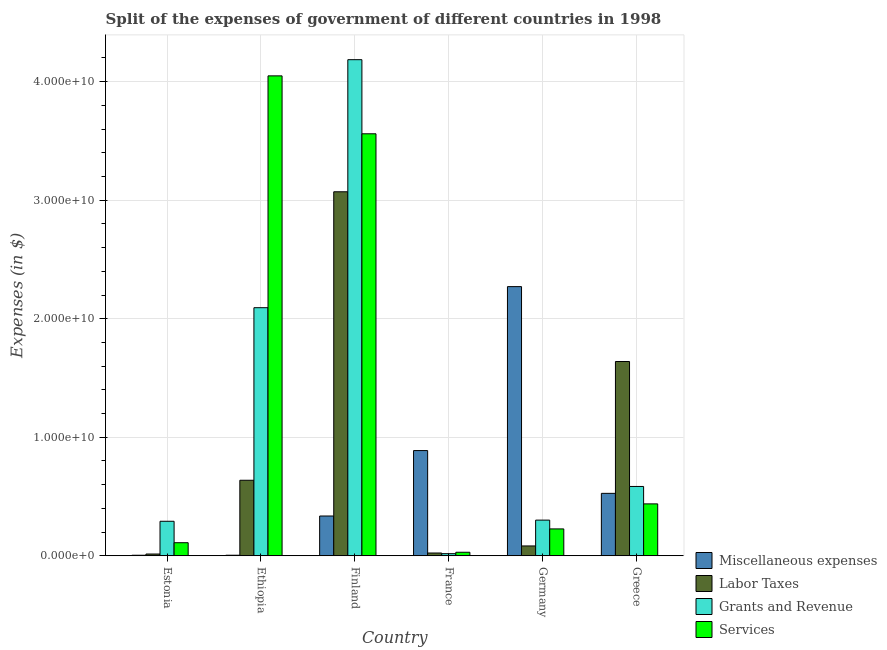Are the number of bars per tick equal to the number of legend labels?
Ensure brevity in your answer.  Yes. How many bars are there on the 6th tick from the right?
Your response must be concise. 4. In how many cases, is the number of bars for a given country not equal to the number of legend labels?
Your response must be concise. 0. What is the amount spent on miscellaneous expenses in Ethiopia?
Offer a very short reply. 4.77e+07. Across all countries, what is the maximum amount spent on labor taxes?
Your answer should be very brief. 3.07e+1. Across all countries, what is the minimum amount spent on miscellaneous expenses?
Keep it short and to the point. 4.71e+07. In which country was the amount spent on services maximum?
Offer a terse response. Ethiopia. What is the total amount spent on services in the graph?
Keep it short and to the point. 8.41e+1. What is the difference between the amount spent on labor taxes in Finland and that in Greece?
Offer a very short reply. 1.43e+1. What is the difference between the amount spent on labor taxes in France and the amount spent on miscellaneous expenses in Finland?
Make the answer very short. -3.12e+09. What is the average amount spent on services per country?
Give a very brief answer. 1.40e+1. What is the difference between the amount spent on services and amount spent on miscellaneous expenses in Ethiopia?
Make the answer very short. 4.04e+1. What is the ratio of the amount spent on services in France to that in Germany?
Make the answer very short. 0.13. Is the difference between the amount spent on labor taxes in Finland and Germany greater than the difference between the amount spent on miscellaneous expenses in Finland and Germany?
Ensure brevity in your answer.  Yes. What is the difference between the highest and the second highest amount spent on grants and revenue?
Make the answer very short. 2.09e+1. What is the difference between the highest and the lowest amount spent on labor taxes?
Provide a succinct answer. 3.06e+1. What does the 3rd bar from the left in Ethiopia represents?
Provide a short and direct response. Grants and Revenue. What does the 1st bar from the right in Estonia represents?
Your answer should be very brief. Services. Are all the bars in the graph horizontal?
Your response must be concise. No. How many countries are there in the graph?
Your response must be concise. 6. What is the difference between two consecutive major ticks on the Y-axis?
Your answer should be very brief. 1.00e+1. Are the values on the major ticks of Y-axis written in scientific E-notation?
Keep it short and to the point. Yes. Does the graph contain grids?
Offer a very short reply. Yes. Where does the legend appear in the graph?
Provide a succinct answer. Bottom right. What is the title of the graph?
Give a very brief answer. Split of the expenses of government of different countries in 1998. Does "Labor Taxes" appear as one of the legend labels in the graph?
Your answer should be compact. Yes. What is the label or title of the X-axis?
Your answer should be very brief. Country. What is the label or title of the Y-axis?
Keep it short and to the point. Expenses (in $). What is the Expenses (in $) in Miscellaneous expenses in Estonia?
Provide a succinct answer. 4.71e+07. What is the Expenses (in $) of Labor Taxes in Estonia?
Your response must be concise. 1.49e+08. What is the Expenses (in $) of Grants and Revenue in Estonia?
Ensure brevity in your answer.  2.91e+09. What is the Expenses (in $) of Services in Estonia?
Keep it short and to the point. 1.10e+09. What is the Expenses (in $) of Miscellaneous expenses in Ethiopia?
Your response must be concise. 4.77e+07. What is the Expenses (in $) of Labor Taxes in Ethiopia?
Give a very brief answer. 6.37e+09. What is the Expenses (in $) in Grants and Revenue in Ethiopia?
Ensure brevity in your answer.  2.09e+1. What is the Expenses (in $) in Services in Ethiopia?
Provide a short and direct response. 4.05e+1. What is the Expenses (in $) of Miscellaneous expenses in Finland?
Keep it short and to the point. 3.36e+09. What is the Expenses (in $) in Labor Taxes in Finland?
Ensure brevity in your answer.  3.07e+1. What is the Expenses (in $) of Grants and Revenue in Finland?
Offer a terse response. 4.19e+1. What is the Expenses (in $) of Services in Finland?
Your answer should be compact. 3.56e+1. What is the Expenses (in $) of Miscellaneous expenses in France?
Your response must be concise. 8.88e+09. What is the Expenses (in $) in Labor Taxes in France?
Make the answer very short. 2.35e+08. What is the Expenses (in $) of Grants and Revenue in France?
Your answer should be compact. 1.80e+08. What is the Expenses (in $) of Services in France?
Make the answer very short. 2.98e+08. What is the Expenses (in $) of Miscellaneous expenses in Germany?
Your answer should be very brief. 2.27e+1. What is the Expenses (in $) in Labor Taxes in Germany?
Offer a terse response. 8.31e+08. What is the Expenses (in $) in Grants and Revenue in Germany?
Your answer should be very brief. 3.01e+09. What is the Expenses (in $) of Services in Germany?
Your answer should be very brief. 2.27e+09. What is the Expenses (in $) in Miscellaneous expenses in Greece?
Give a very brief answer. 5.27e+09. What is the Expenses (in $) of Labor Taxes in Greece?
Provide a short and direct response. 1.64e+1. What is the Expenses (in $) of Grants and Revenue in Greece?
Ensure brevity in your answer.  5.85e+09. What is the Expenses (in $) of Services in Greece?
Offer a terse response. 4.38e+09. Across all countries, what is the maximum Expenses (in $) in Miscellaneous expenses?
Keep it short and to the point. 2.27e+1. Across all countries, what is the maximum Expenses (in $) of Labor Taxes?
Offer a terse response. 3.07e+1. Across all countries, what is the maximum Expenses (in $) in Grants and Revenue?
Provide a short and direct response. 4.19e+1. Across all countries, what is the maximum Expenses (in $) of Services?
Give a very brief answer. 4.05e+1. Across all countries, what is the minimum Expenses (in $) in Miscellaneous expenses?
Provide a short and direct response. 4.71e+07. Across all countries, what is the minimum Expenses (in $) in Labor Taxes?
Provide a succinct answer. 1.49e+08. Across all countries, what is the minimum Expenses (in $) of Grants and Revenue?
Your response must be concise. 1.80e+08. Across all countries, what is the minimum Expenses (in $) in Services?
Keep it short and to the point. 2.98e+08. What is the total Expenses (in $) in Miscellaneous expenses in the graph?
Your answer should be very brief. 4.03e+1. What is the total Expenses (in $) in Labor Taxes in the graph?
Provide a short and direct response. 5.47e+1. What is the total Expenses (in $) in Grants and Revenue in the graph?
Provide a succinct answer. 7.47e+1. What is the total Expenses (in $) in Services in the graph?
Provide a short and direct response. 8.41e+1. What is the difference between the Expenses (in $) of Miscellaneous expenses in Estonia and that in Ethiopia?
Offer a very short reply. -6.00e+05. What is the difference between the Expenses (in $) in Labor Taxes in Estonia and that in Ethiopia?
Give a very brief answer. -6.22e+09. What is the difference between the Expenses (in $) of Grants and Revenue in Estonia and that in Ethiopia?
Your response must be concise. -1.80e+1. What is the difference between the Expenses (in $) of Services in Estonia and that in Ethiopia?
Give a very brief answer. -3.94e+1. What is the difference between the Expenses (in $) in Miscellaneous expenses in Estonia and that in Finland?
Ensure brevity in your answer.  -3.31e+09. What is the difference between the Expenses (in $) in Labor Taxes in Estonia and that in Finland?
Your response must be concise. -3.06e+1. What is the difference between the Expenses (in $) of Grants and Revenue in Estonia and that in Finland?
Offer a very short reply. -3.89e+1. What is the difference between the Expenses (in $) in Services in Estonia and that in Finland?
Make the answer very short. -3.45e+1. What is the difference between the Expenses (in $) of Miscellaneous expenses in Estonia and that in France?
Your answer should be very brief. -8.83e+09. What is the difference between the Expenses (in $) of Labor Taxes in Estonia and that in France?
Offer a very short reply. -8.53e+07. What is the difference between the Expenses (in $) of Grants and Revenue in Estonia and that in France?
Offer a very short reply. 2.73e+09. What is the difference between the Expenses (in $) of Services in Estonia and that in France?
Keep it short and to the point. 8.05e+08. What is the difference between the Expenses (in $) in Miscellaneous expenses in Estonia and that in Germany?
Give a very brief answer. -2.27e+1. What is the difference between the Expenses (in $) in Labor Taxes in Estonia and that in Germany?
Your answer should be very brief. -6.82e+08. What is the difference between the Expenses (in $) in Grants and Revenue in Estonia and that in Germany?
Your answer should be very brief. -9.74e+07. What is the difference between the Expenses (in $) of Services in Estonia and that in Germany?
Give a very brief answer. -1.16e+09. What is the difference between the Expenses (in $) of Miscellaneous expenses in Estonia and that in Greece?
Provide a succinct answer. -5.22e+09. What is the difference between the Expenses (in $) of Labor Taxes in Estonia and that in Greece?
Your response must be concise. -1.62e+1. What is the difference between the Expenses (in $) of Grants and Revenue in Estonia and that in Greece?
Make the answer very short. -2.94e+09. What is the difference between the Expenses (in $) of Services in Estonia and that in Greece?
Your answer should be compact. -3.28e+09. What is the difference between the Expenses (in $) of Miscellaneous expenses in Ethiopia and that in Finland?
Offer a terse response. -3.31e+09. What is the difference between the Expenses (in $) of Labor Taxes in Ethiopia and that in Finland?
Ensure brevity in your answer.  -2.43e+1. What is the difference between the Expenses (in $) of Grants and Revenue in Ethiopia and that in Finland?
Offer a terse response. -2.09e+1. What is the difference between the Expenses (in $) in Services in Ethiopia and that in Finland?
Make the answer very short. 4.89e+09. What is the difference between the Expenses (in $) of Miscellaneous expenses in Ethiopia and that in France?
Your answer should be very brief. -8.83e+09. What is the difference between the Expenses (in $) of Labor Taxes in Ethiopia and that in France?
Keep it short and to the point. 6.14e+09. What is the difference between the Expenses (in $) of Grants and Revenue in Ethiopia and that in France?
Provide a succinct answer. 2.08e+1. What is the difference between the Expenses (in $) of Services in Ethiopia and that in France?
Your answer should be very brief. 4.02e+1. What is the difference between the Expenses (in $) in Miscellaneous expenses in Ethiopia and that in Germany?
Your answer should be compact. -2.27e+1. What is the difference between the Expenses (in $) of Labor Taxes in Ethiopia and that in Germany?
Make the answer very short. 5.54e+09. What is the difference between the Expenses (in $) in Grants and Revenue in Ethiopia and that in Germany?
Your answer should be very brief. 1.79e+1. What is the difference between the Expenses (in $) of Services in Ethiopia and that in Germany?
Provide a succinct answer. 3.82e+1. What is the difference between the Expenses (in $) in Miscellaneous expenses in Ethiopia and that in Greece?
Your response must be concise. -5.22e+09. What is the difference between the Expenses (in $) of Labor Taxes in Ethiopia and that in Greece?
Your answer should be compact. -1.00e+1. What is the difference between the Expenses (in $) in Grants and Revenue in Ethiopia and that in Greece?
Offer a very short reply. 1.51e+1. What is the difference between the Expenses (in $) in Services in Ethiopia and that in Greece?
Give a very brief answer. 3.61e+1. What is the difference between the Expenses (in $) of Miscellaneous expenses in Finland and that in France?
Keep it short and to the point. -5.52e+09. What is the difference between the Expenses (in $) of Labor Taxes in Finland and that in France?
Give a very brief answer. 3.05e+1. What is the difference between the Expenses (in $) of Grants and Revenue in Finland and that in France?
Your answer should be very brief. 4.17e+1. What is the difference between the Expenses (in $) of Services in Finland and that in France?
Your response must be concise. 3.53e+1. What is the difference between the Expenses (in $) in Miscellaneous expenses in Finland and that in Germany?
Provide a short and direct response. -1.94e+1. What is the difference between the Expenses (in $) in Labor Taxes in Finland and that in Germany?
Offer a very short reply. 2.99e+1. What is the difference between the Expenses (in $) in Grants and Revenue in Finland and that in Germany?
Make the answer very short. 3.88e+1. What is the difference between the Expenses (in $) in Services in Finland and that in Germany?
Keep it short and to the point. 3.33e+1. What is the difference between the Expenses (in $) of Miscellaneous expenses in Finland and that in Greece?
Keep it short and to the point. -1.91e+09. What is the difference between the Expenses (in $) of Labor Taxes in Finland and that in Greece?
Provide a short and direct response. 1.43e+1. What is the difference between the Expenses (in $) of Grants and Revenue in Finland and that in Greece?
Offer a very short reply. 3.60e+1. What is the difference between the Expenses (in $) in Services in Finland and that in Greece?
Ensure brevity in your answer.  3.12e+1. What is the difference between the Expenses (in $) in Miscellaneous expenses in France and that in Germany?
Provide a short and direct response. -1.38e+1. What is the difference between the Expenses (in $) of Labor Taxes in France and that in Germany?
Provide a short and direct response. -5.97e+08. What is the difference between the Expenses (in $) of Grants and Revenue in France and that in Germany?
Give a very brief answer. -2.83e+09. What is the difference between the Expenses (in $) in Services in France and that in Germany?
Offer a terse response. -1.97e+09. What is the difference between the Expenses (in $) in Miscellaneous expenses in France and that in Greece?
Make the answer very short. 3.61e+09. What is the difference between the Expenses (in $) of Labor Taxes in France and that in Greece?
Ensure brevity in your answer.  -1.62e+1. What is the difference between the Expenses (in $) in Grants and Revenue in France and that in Greece?
Provide a short and direct response. -5.67e+09. What is the difference between the Expenses (in $) of Services in France and that in Greece?
Provide a succinct answer. -4.08e+09. What is the difference between the Expenses (in $) in Miscellaneous expenses in Germany and that in Greece?
Provide a succinct answer. 1.74e+1. What is the difference between the Expenses (in $) of Labor Taxes in Germany and that in Greece?
Your answer should be compact. -1.56e+1. What is the difference between the Expenses (in $) of Grants and Revenue in Germany and that in Greece?
Give a very brief answer. -2.84e+09. What is the difference between the Expenses (in $) of Services in Germany and that in Greece?
Make the answer very short. -2.11e+09. What is the difference between the Expenses (in $) in Miscellaneous expenses in Estonia and the Expenses (in $) in Labor Taxes in Ethiopia?
Your response must be concise. -6.33e+09. What is the difference between the Expenses (in $) in Miscellaneous expenses in Estonia and the Expenses (in $) in Grants and Revenue in Ethiopia?
Offer a terse response. -2.09e+1. What is the difference between the Expenses (in $) in Miscellaneous expenses in Estonia and the Expenses (in $) in Services in Ethiopia?
Provide a short and direct response. -4.04e+1. What is the difference between the Expenses (in $) in Labor Taxes in Estonia and the Expenses (in $) in Grants and Revenue in Ethiopia?
Make the answer very short. -2.08e+1. What is the difference between the Expenses (in $) of Labor Taxes in Estonia and the Expenses (in $) of Services in Ethiopia?
Offer a terse response. -4.03e+1. What is the difference between the Expenses (in $) in Grants and Revenue in Estonia and the Expenses (in $) in Services in Ethiopia?
Provide a short and direct response. -3.76e+1. What is the difference between the Expenses (in $) in Miscellaneous expenses in Estonia and the Expenses (in $) in Labor Taxes in Finland?
Your answer should be compact. -3.07e+1. What is the difference between the Expenses (in $) in Miscellaneous expenses in Estonia and the Expenses (in $) in Grants and Revenue in Finland?
Your response must be concise. -4.18e+1. What is the difference between the Expenses (in $) of Miscellaneous expenses in Estonia and the Expenses (in $) of Services in Finland?
Your response must be concise. -3.56e+1. What is the difference between the Expenses (in $) in Labor Taxes in Estonia and the Expenses (in $) in Grants and Revenue in Finland?
Provide a short and direct response. -4.17e+1. What is the difference between the Expenses (in $) in Labor Taxes in Estonia and the Expenses (in $) in Services in Finland?
Offer a terse response. -3.55e+1. What is the difference between the Expenses (in $) in Grants and Revenue in Estonia and the Expenses (in $) in Services in Finland?
Your response must be concise. -3.27e+1. What is the difference between the Expenses (in $) of Miscellaneous expenses in Estonia and the Expenses (in $) of Labor Taxes in France?
Your answer should be compact. -1.88e+08. What is the difference between the Expenses (in $) in Miscellaneous expenses in Estonia and the Expenses (in $) in Grants and Revenue in France?
Provide a short and direct response. -1.33e+08. What is the difference between the Expenses (in $) of Miscellaneous expenses in Estonia and the Expenses (in $) of Services in France?
Provide a short and direct response. -2.51e+08. What is the difference between the Expenses (in $) in Labor Taxes in Estonia and the Expenses (in $) in Grants and Revenue in France?
Your answer should be compact. -3.06e+07. What is the difference between the Expenses (in $) of Labor Taxes in Estonia and the Expenses (in $) of Services in France?
Your answer should be very brief. -1.49e+08. What is the difference between the Expenses (in $) in Grants and Revenue in Estonia and the Expenses (in $) in Services in France?
Your answer should be compact. 2.61e+09. What is the difference between the Expenses (in $) in Miscellaneous expenses in Estonia and the Expenses (in $) in Labor Taxes in Germany?
Keep it short and to the point. -7.84e+08. What is the difference between the Expenses (in $) in Miscellaneous expenses in Estonia and the Expenses (in $) in Grants and Revenue in Germany?
Offer a terse response. -2.96e+09. What is the difference between the Expenses (in $) in Miscellaneous expenses in Estonia and the Expenses (in $) in Services in Germany?
Make the answer very short. -2.22e+09. What is the difference between the Expenses (in $) in Labor Taxes in Estonia and the Expenses (in $) in Grants and Revenue in Germany?
Your answer should be compact. -2.86e+09. What is the difference between the Expenses (in $) of Labor Taxes in Estonia and the Expenses (in $) of Services in Germany?
Make the answer very short. -2.12e+09. What is the difference between the Expenses (in $) of Grants and Revenue in Estonia and the Expenses (in $) of Services in Germany?
Provide a short and direct response. 6.45e+08. What is the difference between the Expenses (in $) in Miscellaneous expenses in Estonia and the Expenses (in $) in Labor Taxes in Greece?
Offer a terse response. -1.63e+1. What is the difference between the Expenses (in $) of Miscellaneous expenses in Estonia and the Expenses (in $) of Grants and Revenue in Greece?
Offer a very short reply. -5.80e+09. What is the difference between the Expenses (in $) of Miscellaneous expenses in Estonia and the Expenses (in $) of Services in Greece?
Your answer should be compact. -4.33e+09. What is the difference between the Expenses (in $) of Labor Taxes in Estonia and the Expenses (in $) of Grants and Revenue in Greece?
Your response must be concise. -5.70e+09. What is the difference between the Expenses (in $) in Labor Taxes in Estonia and the Expenses (in $) in Services in Greece?
Your response must be concise. -4.23e+09. What is the difference between the Expenses (in $) of Grants and Revenue in Estonia and the Expenses (in $) of Services in Greece?
Provide a succinct answer. -1.47e+09. What is the difference between the Expenses (in $) of Miscellaneous expenses in Ethiopia and the Expenses (in $) of Labor Taxes in Finland?
Ensure brevity in your answer.  -3.07e+1. What is the difference between the Expenses (in $) in Miscellaneous expenses in Ethiopia and the Expenses (in $) in Grants and Revenue in Finland?
Provide a succinct answer. -4.18e+1. What is the difference between the Expenses (in $) of Miscellaneous expenses in Ethiopia and the Expenses (in $) of Services in Finland?
Provide a succinct answer. -3.56e+1. What is the difference between the Expenses (in $) in Labor Taxes in Ethiopia and the Expenses (in $) in Grants and Revenue in Finland?
Your answer should be compact. -3.55e+1. What is the difference between the Expenses (in $) of Labor Taxes in Ethiopia and the Expenses (in $) of Services in Finland?
Give a very brief answer. -2.92e+1. What is the difference between the Expenses (in $) in Grants and Revenue in Ethiopia and the Expenses (in $) in Services in Finland?
Your answer should be very brief. -1.47e+1. What is the difference between the Expenses (in $) of Miscellaneous expenses in Ethiopia and the Expenses (in $) of Labor Taxes in France?
Your answer should be compact. -1.87e+08. What is the difference between the Expenses (in $) of Miscellaneous expenses in Ethiopia and the Expenses (in $) of Grants and Revenue in France?
Offer a terse response. -1.32e+08. What is the difference between the Expenses (in $) in Miscellaneous expenses in Ethiopia and the Expenses (in $) in Services in France?
Offer a terse response. -2.50e+08. What is the difference between the Expenses (in $) in Labor Taxes in Ethiopia and the Expenses (in $) in Grants and Revenue in France?
Make the answer very short. 6.19e+09. What is the difference between the Expenses (in $) of Labor Taxes in Ethiopia and the Expenses (in $) of Services in France?
Your answer should be compact. 6.08e+09. What is the difference between the Expenses (in $) of Grants and Revenue in Ethiopia and the Expenses (in $) of Services in France?
Ensure brevity in your answer.  2.06e+1. What is the difference between the Expenses (in $) of Miscellaneous expenses in Ethiopia and the Expenses (in $) of Labor Taxes in Germany?
Ensure brevity in your answer.  -7.84e+08. What is the difference between the Expenses (in $) of Miscellaneous expenses in Ethiopia and the Expenses (in $) of Grants and Revenue in Germany?
Your answer should be compact. -2.96e+09. What is the difference between the Expenses (in $) of Miscellaneous expenses in Ethiopia and the Expenses (in $) of Services in Germany?
Offer a terse response. -2.22e+09. What is the difference between the Expenses (in $) of Labor Taxes in Ethiopia and the Expenses (in $) of Grants and Revenue in Germany?
Your answer should be compact. 3.36e+09. What is the difference between the Expenses (in $) of Labor Taxes in Ethiopia and the Expenses (in $) of Services in Germany?
Offer a very short reply. 4.11e+09. What is the difference between the Expenses (in $) of Grants and Revenue in Ethiopia and the Expenses (in $) of Services in Germany?
Offer a very short reply. 1.87e+1. What is the difference between the Expenses (in $) in Miscellaneous expenses in Ethiopia and the Expenses (in $) in Labor Taxes in Greece?
Your answer should be very brief. -1.63e+1. What is the difference between the Expenses (in $) in Miscellaneous expenses in Ethiopia and the Expenses (in $) in Grants and Revenue in Greece?
Offer a very short reply. -5.80e+09. What is the difference between the Expenses (in $) of Miscellaneous expenses in Ethiopia and the Expenses (in $) of Services in Greece?
Keep it short and to the point. -4.33e+09. What is the difference between the Expenses (in $) of Labor Taxes in Ethiopia and the Expenses (in $) of Grants and Revenue in Greece?
Make the answer very short. 5.24e+08. What is the difference between the Expenses (in $) in Labor Taxes in Ethiopia and the Expenses (in $) in Services in Greece?
Ensure brevity in your answer.  1.99e+09. What is the difference between the Expenses (in $) in Grants and Revenue in Ethiopia and the Expenses (in $) in Services in Greece?
Your answer should be very brief. 1.66e+1. What is the difference between the Expenses (in $) in Miscellaneous expenses in Finland and the Expenses (in $) in Labor Taxes in France?
Your answer should be very brief. 3.12e+09. What is the difference between the Expenses (in $) in Miscellaneous expenses in Finland and the Expenses (in $) in Grants and Revenue in France?
Your response must be concise. 3.18e+09. What is the difference between the Expenses (in $) in Miscellaneous expenses in Finland and the Expenses (in $) in Services in France?
Give a very brief answer. 3.06e+09. What is the difference between the Expenses (in $) in Labor Taxes in Finland and the Expenses (in $) in Grants and Revenue in France?
Provide a short and direct response. 3.05e+1. What is the difference between the Expenses (in $) in Labor Taxes in Finland and the Expenses (in $) in Services in France?
Offer a terse response. 3.04e+1. What is the difference between the Expenses (in $) in Grants and Revenue in Finland and the Expenses (in $) in Services in France?
Your answer should be very brief. 4.16e+1. What is the difference between the Expenses (in $) in Miscellaneous expenses in Finland and the Expenses (in $) in Labor Taxes in Germany?
Keep it short and to the point. 2.52e+09. What is the difference between the Expenses (in $) in Miscellaneous expenses in Finland and the Expenses (in $) in Grants and Revenue in Germany?
Your answer should be very brief. 3.46e+08. What is the difference between the Expenses (in $) in Miscellaneous expenses in Finland and the Expenses (in $) in Services in Germany?
Your response must be concise. 1.09e+09. What is the difference between the Expenses (in $) in Labor Taxes in Finland and the Expenses (in $) in Grants and Revenue in Germany?
Give a very brief answer. 2.77e+1. What is the difference between the Expenses (in $) in Labor Taxes in Finland and the Expenses (in $) in Services in Germany?
Provide a short and direct response. 2.84e+1. What is the difference between the Expenses (in $) of Grants and Revenue in Finland and the Expenses (in $) of Services in Germany?
Make the answer very short. 3.96e+1. What is the difference between the Expenses (in $) of Miscellaneous expenses in Finland and the Expenses (in $) of Labor Taxes in Greece?
Your response must be concise. -1.30e+1. What is the difference between the Expenses (in $) of Miscellaneous expenses in Finland and the Expenses (in $) of Grants and Revenue in Greece?
Offer a very short reply. -2.49e+09. What is the difference between the Expenses (in $) of Miscellaneous expenses in Finland and the Expenses (in $) of Services in Greece?
Your response must be concise. -1.02e+09. What is the difference between the Expenses (in $) in Labor Taxes in Finland and the Expenses (in $) in Grants and Revenue in Greece?
Provide a succinct answer. 2.49e+1. What is the difference between the Expenses (in $) of Labor Taxes in Finland and the Expenses (in $) of Services in Greece?
Keep it short and to the point. 2.63e+1. What is the difference between the Expenses (in $) of Grants and Revenue in Finland and the Expenses (in $) of Services in Greece?
Offer a very short reply. 3.75e+1. What is the difference between the Expenses (in $) in Miscellaneous expenses in France and the Expenses (in $) in Labor Taxes in Germany?
Provide a short and direct response. 8.05e+09. What is the difference between the Expenses (in $) of Miscellaneous expenses in France and the Expenses (in $) of Grants and Revenue in Germany?
Your answer should be compact. 5.87e+09. What is the difference between the Expenses (in $) in Miscellaneous expenses in France and the Expenses (in $) in Services in Germany?
Your answer should be very brief. 6.61e+09. What is the difference between the Expenses (in $) of Labor Taxes in France and the Expenses (in $) of Grants and Revenue in Germany?
Offer a very short reply. -2.78e+09. What is the difference between the Expenses (in $) of Labor Taxes in France and the Expenses (in $) of Services in Germany?
Keep it short and to the point. -2.03e+09. What is the difference between the Expenses (in $) of Grants and Revenue in France and the Expenses (in $) of Services in Germany?
Provide a succinct answer. -2.09e+09. What is the difference between the Expenses (in $) in Miscellaneous expenses in France and the Expenses (in $) in Labor Taxes in Greece?
Your answer should be very brief. -7.51e+09. What is the difference between the Expenses (in $) of Miscellaneous expenses in France and the Expenses (in $) of Grants and Revenue in Greece?
Provide a succinct answer. 3.03e+09. What is the difference between the Expenses (in $) of Miscellaneous expenses in France and the Expenses (in $) of Services in Greece?
Keep it short and to the point. 4.50e+09. What is the difference between the Expenses (in $) of Labor Taxes in France and the Expenses (in $) of Grants and Revenue in Greece?
Offer a terse response. -5.61e+09. What is the difference between the Expenses (in $) in Labor Taxes in France and the Expenses (in $) in Services in Greece?
Offer a terse response. -4.14e+09. What is the difference between the Expenses (in $) in Grants and Revenue in France and the Expenses (in $) in Services in Greece?
Your response must be concise. -4.20e+09. What is the difference between the Expenses (in $) of Miscellaneous expenses in Germany and the Expenses (in $) of Labor Taxes in Greece?
Make the answer very short. 6.32e+09. What is the difference between the Expenses (in $) of Miscellaneous expenses in Germany and the Expenses (in $) of Grants and Revenue in Greece?
Your response must be concise. 1.69e+1. What is the difference between the Expenses (in $) of Miscellaneous expenses in Germany and the Expenses (in $) of Services in Greece?
Your answer should be very brief. 1.83e+1. What is the difference between the Expenses (in $) of Labor Taxes in Germany and the Expenses (in $) of Grants and Revenue in Greece?
Ensure brevity in your answer.  -5.02e+09. What is the difference between the Expenses (in $) in Labor Taxes in Germany and the Expenses (in $) in Services in Greece?
Make the answer very short. -3.55e+09. What is the difference between the Expenses (in $) of Grants and Revenue in Germany and the Expenses (in $) of Services in Greece?
Give a very brief answer. -1.37e+09. What is the average Expenses (in $) in Miscellaneous expenses per country?
Your answer should be very brief. 6.72e+09. What is the average Expenses (in $) in Labor Taxes per country?
Make the answer very short. 9.12e+09. What is the average Expenses (in $) of Grants and Revenue per country?
Offer a terse response. 1.25e+1. What is the average Expenses (in $) of Services per country?
Give a very brief answer. 1.40e+1. What is the difference between the Expenses (in $) of Miscellaneous expenses and Expenses (in $) of Labor Taxes in Estonia?
Offer a terse response. -1.02e+08. What is the difference between the Expenses (in $) in Miscellaneous expenses and Expenses (in $) in Grants and Revenue in Estonia?
Offer a very short reply. -2.87e+09. What is the difference between the Expenses (in $) in Miscellaneous expenses and Expenses (in $) in Services in Estonia?
Your answer should be very brief. -1.06e+09. What is the difference between the Expenses (in $) in Labor Taxes and Expenses (in $) in Grants and Revenue in Estonia?
Your answer should be compact. -2.76e+09. What is the difference between the Expenses (in $) in Labor Taxes and Expenses (in $) in Services in Estonia?
Offer a very short reply. -9.54e+08. What is the difference between the Expenses (in $) of Grants and Revenue and Expenses (in $) of Services in Estonia?
Your answer should be very brief. 1.81e+09. What is the difference between the Expenses (in $) of Miscellaneous expenses and Expenses (in $) of Labor Taxes in Ethiopia?
Offer a very short reply. -6.33e+09. What is the difference between the Expenses (in $) in Miscellaneous expenses and Expenses (in $) in Grants and Revenue in Ethiopia?
Your answer should be very brief. -2.09e+1. What is the difference between the Expenses (in $) of Miscellaneous expenses and Expenses (in $) of Services in Ethiopia?
Provide a short and direct response. -4.04e+1. What is the difference between the Expenses (in $) in Labor Taxes and Expenses (in $) in Grants and Revenue in Ethiopia?
Give a very brief answer. -1.46e+1. What is the difference between the Expenses (in $) in Labor Taxes and Expenses (in $) in Services in Ethiopia?
Offer a very short reply. -3.41e+1. What is the difference between the Expenses (in $) in Grants and Revenue and Expenses (in $) in Services in Ethiopia?
Provide a succinct answer. -1.96e+1. What is the difference between the Expenses (in $) in Miscellaneous expenses and Expenses (in $) in Labor Taxes in Finland?
Provide a short and direct response. -2.74e+1. What is the difference between the Expenses (in $) in Miscellaneous expenses and Expenses (in $) in Grants and Revenue in Finland?
Your answer should be very brief. -3.85e+1. What is the difference between the Expenses (in $) of Miscellaneous expenses and Expenses (in $) of Services in Finland?
Keep it short and to the point. -3.22e+1. What is the difference between the Expenses (in $) in Labor Taxes and Expenses (in $) in Grants and Revenue in Finland?
Your answer should be compact. -1.11e+1. What is the difference between the Expenses (in $) in Labor Taxes and Expenses (in $) in Services in Finland?
Give a very brief answer. -4.89e+09. What is the difference between the Expenses (in $) in Grants and Revenue and Expenses (in $) in Services in Finland?
Offer a very short reply. 6.25e+09. What is the difference between the Expenses (in $) of Miscellaneous expenses and Expenses (in $) of Labor Taxes in France?
Offer a terse response. 8.64e+09. What is the difference between the Expenses (in $) of Miscellaneous expenses and Expenses (in $) of Grants and Revenue in France?
Ensure brevity in your answer.  8.70e+09. What is the difference between the Expenses (in $) in Miscellaneous expenses and Expenses (in $) in Services in France?
Provide a succinct answer. 8.58e+09. What is the difference between the Expenses (in $) in Labor Taxes and Expenses (in $) in Grants and Revenue in France?
Give a very brief answer. 5.47e+07. What is the difference between the Expenses (in $) of Labor Taxes and Expenses (in $) of Services in France?
Make the answer very short. -6.32e+07. What is the difference between the Expenses (in $) in Grants and Revenue and Expenses (in $) in Services in France?
Provide a short and direct response. -1.18e+08. What is the difference between the Expenses (in $) in Miscellaneous expenses and Expenses (in $) in Labor Taxes in Germany?
Your response must be concise. 2.19e+1. What is the difference between the Expenses (in $) in Miscellaneous expenses and Expenses (in $) in Grants and Revenue in Germany?
Your response must be concise. 1.97e+1. What is the difference between the Expenses (in $) of Miscellaneous expenses and Expenses (in $) of Services in Germany?
Provide a succinct answer. 2.04e+1. What is the difference between the Expenses (in $) in Labor Taxes and Expenses (in $) in Grants and Revenue in Germany?
Give a very brief answer. -2.18e+09. What is the difference between the Expenses (in $) in Labor Taxes and Expenses (in $) in Services in Germany?
Offer a very short reply. -1.44e+09. What is the difference between the Expenses (in $) in Grants and Revenue and Expenses (in $) in Services in Germany?
Offer a terse response. 7.42e+08. What is the difference between the Expenses (in $) of Miscellaneous expenses and Expenses (in $) of Labor Taxes in Greece?
Ensure brevity in your answer.  -1.11e+1. What is the difference between the Expenses (in $) of Miscellaneous expenses and Expenses (in $) of Grants and Revenue in Greece?
Ensure brevity in your answer.  -5.81e+08. What is the difference between the Expenses (in $) of Miscellaneous expenses and Expenses (in $) of Services in Greece?
Provide a succinct answer. 8.89e+08. What is the difference between the Expenses (in $) of Labor Taxes and Expenses (in $) of Grants and Revenue in Greece?
Your answer should be compact. 1.05e+1. What is the difference between the Expenses (in $) in Labor Taxes and Expenses (in $) in Services in Greece?
Your answer should be compact. 1.20e+1. What is the difference between the Expenses (in $) in Grants and Revenue and Expenses (in $) in Services in Greece?
Provide a short and direct response. 1.47e+09. What is the ratio of the Expenses (in $) of Miscellaneous expenses in Estonia to that in Ethiopia?
Your answer should be compact. 0.99. What is the ratio of the Expenses (in $) in Labor Taxes in Estonia to that in Ethiopia?
Your response must be concise. 0.02. What is the ratio of the Expenses (in $) in Grants and Revenue in Estonia to that in Ethiopia?
Your answer should be very brief. 0.14. What is the ratio of the Expenses (in $) of Services in Estonia to that in Ethiopia?
Your response must be concise. 0.03. What is the ratio of the Expenses (in $) of Miscellaneous expenses in Estonia to that in Finland?
Your response must be concise. 0.01. What is the ratio of the Expenses (in $) in Labor Taxes in Estonia to that in Finland?
Ensure brevity in your answer.  0. What is the ratio of the Expenses (in $) of Grants and Revenue in Estonia to that in Finland?
Your answer should be very brief. 0.07. What is the ratio of the Expenses (in $) of Services in Estonia to that in Finland?
Offer a very short reply. 0.03. What is the ratio of the Expenses (in $) in Miscellaneous expenses in Estonia to that in France?
Make the answer very short. 0.01. What is the ratio of the Expenses (in $) of Labor Taxes in Estonia to that in France?
Your answer should be very brief. 0.64. What is the ratio of the Expenses (in $) in Grants and Revenue in Estonia to that in France?
Provide a succinct answer. 16.17. What is the ratio of the Expenses (in $) in Services in Estonia to that in France?
Ensure brevity in your answer.  3.7. What is the ratio of the Expenses (in $) of Miscellaneous expenses in Estonia to that in Germany?
Ensure brevity in your answer.  0. What is the ratio of the Expenses (in $) of Labor Taxes in Estonia to that in Germany?
Make the answer very short. 0.18. What is the ratio of the Expenses (in $) of Grants and Revenue in Estonia to that in Germany?
Offer a terse response. 0.97. What is the ratio of the Expenses (in $) in Services in Estonia to that in Germany?
Provide a succinct answer. 0.49. What is the ratio of the Expenses (in $) in Miscellaneous expenses in Estonia to that in Greece?
Provide a short and direct response. 0.01. What is the ratio of the Expenses (in $) of Labor Taxes in Estonia to that in Greece?
Your answer should be compact. 0.01. What is the ratio of the Expenses (in $) in Grants and Revenue in Estonia to that in Greece?
Ensure brevity in your answer.  0.5. What is the ratio of the Expenses (in $) of Services in Estonia to that in Greece?
Offer a terse response. 0.25. What is the ratio of the Expenses (in $) of Miscellaneous expenses in Ethiopia to that in Finland?
Your response must be concise. 0.01. What is the ratio of the Expenses (in $) of Labor Taxes in Ethiopia to that in Finland?
Give a very brief answer. 0.21. What is the ratio of the Expenses (in $) in Grants and Revenue in Ethiopia to that in Finland?
Ensure brevity in your answer.  0.5. What is the ratio of the Expenses (in $) of Services in Ethiopia to that in Finland?
Your answer should be very brief. 1.14. What is the ratio of the Expenses (in $) in Miscellaneous expenses in Ethiopia to that in France?
Provide a succinct answer. 0.01. What is the ratio of the Expenses (in $) in Labor Taxes in Ethiopia to that in France?
Ensure brevity in your answer.  27.14. What is the ratio of the Expenses (in $) in Grants and Revenue in Ethiopia to that in France?
Give a very brief answer. 116.22. What is the ratio of the Expenses (in $) of Services in Ethiopia to that in France?
Your answer should be compact. 135.88. What is the ratio of the Expenses (in $) of Miscellaneous expenses in Ethiopia to that in Germany?
Provide a short and direct response. 0. What is the ratio of the Expenses (in $) in Labor Taxes in Ethiopia to that in Germany?
Offer a terse response. 7.67. What is the ratio of the Expenses (in $) of Grants and Revenue in Ethiopia to that in Germany?
Provide a succinct answer. 6.95. What is the ratio of the Expenses (in $) in Services in Ethiopia to that in Germany?
Your answer should be very brief. 17.86. What is the ratio of the Expenses (in $) in Miscellaneous expenses in Ethiopia to that in Greece?
Provide a short and direct response. 0.01. What is the ratio of the Expenses (in $) in Labor Taxes in Ethiopia to that in Greece?
Give a very brief answer. 0.39. What is the ratio of the Expenses (in $) of Grants and Revenue in Ethiopia to that in Greece?
Offer a very short reply. 3.58. What is the ratio of the Expenses (in $) of Services in Ethiopia to that in Greece?
Provide a succinct answer. 9.25. What is the ratio of the Expenses (in $) in Miscellaneous expenses in Finland to that in France?
Provide a short and direct response. 0.38. What is the ratio of the Expenses (in $) of Labor Taxes in Finland to that in France?
Offer a terse response. 130.8. What is the ratio of the Expenses (in $) in Grants and Revenue in Finland to that in France?
Your answer should be very brief. 232.4. What is the ratio of the Expenses (in $) in Services in Finland to that in France?
Keep it short and to the point. 119.47. What is the ratio of the Expenses (in $) in Miscellaneous expenses in Finland to that in Germany?
Your answer should be very brief. 0.15. What is the ratio of the Expenses (in $) in Labor Taxes in Finland to that in Germany?
Provide a short and direct response. 36.94. What is the ratio of the Expenses (in $) in Grants and Revenue in Finland to that in Germany?
Provide a short and direct response. 13.91. What is the ratio of the Expenses (in $) in Services in Finland to that in Germany?
Your answer should be very brief. 15.7. What is the ratio of the Expenses (in $) of Miscellaneous expenses in Finland to that in Greece?
Your answer should be compact. 0.64. What is the ratio of the Expenses (in $) of Labor Taxes in Finland to that in Greece?
Your answer should be very brief. 1.87. What is the ratio of the Expenses (in $) of Grants and Revenue in Finland to that in Greece?
Offer a terse response. 7.16. What is the ratio of the Expenses (in $) in Services in Finland to that in Greece?
Keep it short and to the point. 8.13. What is the ratio of the Expenses (in $) of Miscellaneous expenses in France to that in Germany?
Offer a terse response. 0.39. What is the ratio of the Expenses (in $) in Labor Taxes in France to that in Germany?
Your response must be concise. 0.28. What is the ratio of the Expenses (in $) in Grants and Revenue in France to that in Germany?
Provide a succinct answer. 0.06. What is the ratio of the Expenses (in $) in Services in France to that in Germany?
Offer a terse response. 0.13. What is the ratio of the Expenses (in $) in Miscellaneous expenses in France to that in Greece?
Offer a very short reply. 1.69. What is the ratio of the Expenses (in $) in Labor Taxes in France to that in Greece?
Provide a succinct answer. 0.01. What is the ratio of the Expenses (in $) in Grants and Revenue in France to that in Greece?
Give a very brief answer. 0.03. What is the ratio of the Expenses (in $) in Services in France to that in Greece?
Provide a succinct answer. 0.07. What is the ratio of the Expenses (in $) in Miscellaneous expenses in Germany to that in Greece?
Offer a terse response. 4.31. What is the ratio of the Expenses (in $) in Labor Taxes in Germany to that in Greece?
Provide a short and direct response. 0.05. What is the ratio of the Expenses (in $) of Grants and Revenue in Germany to that in Greece?
Your response must be concise. 0.51. What is the ratio of the Expenses (in $) of Services in Germany to that in Greece?
Make the answer very short. 0.52. What is the difference between the highest and the second highest Expenses (in $) of Miscellaneous expenses?
Give a very brief answer. 1.38e+1. What is the difference between the highest and the second highest Expenses (in $) in Labor Taxes?
Your answer should be very brief. 1.43e+1. What is the difference between the highest and the second highest Expenses (in $) of Grants and Revenue?
Your answer should be very brief. 2.09e+1. What is the difference between the highest and the second highest Expenses (in $) in Services?
Provide a short and direct response. 4.89e+09. What is the difference between the highest and the lowest Expenses (in $) in Miscellaneous expenses?
Your response must be concise. 2.27e+1. What is the difference between the highest and the lowest Expenses (in $) in Labor Taxes?
Your answer should be compact. 3.06e+1. What is the difference between the highest and the lowest Expenses (in $) in Grants and Revenue?
Keep it short and to the point. 4.17e+1. What is the difference between the highest and the lowest Expenses (in $) of Services?
Ensure brevity in your answer.  4.02e+1. 